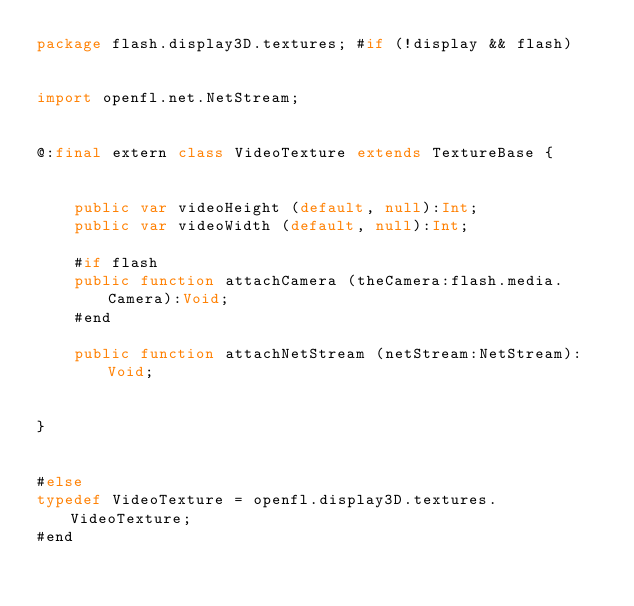<code> <loc_0><loc_0><loc_500><loc_500><_Haxe_>package flash.display3D.textures; #if (!display && flash)


import openfl.net.NetStream;


@:final extern class VideoTexture extends TextureBase {
	
	
	public var videoHeight (default, null):Int;
	public var videoWidth (default, null):Int;
	
	#if flash
	public function attachCamera (theCamera:flash.media.Camera):Void;
	#end
	
	public function attachNetStream (netStream:NetStream):Void;
	
	
}


#else
typedef VideoTexture = openfl.display3D.textures.VideoTexture;
#end</code> 